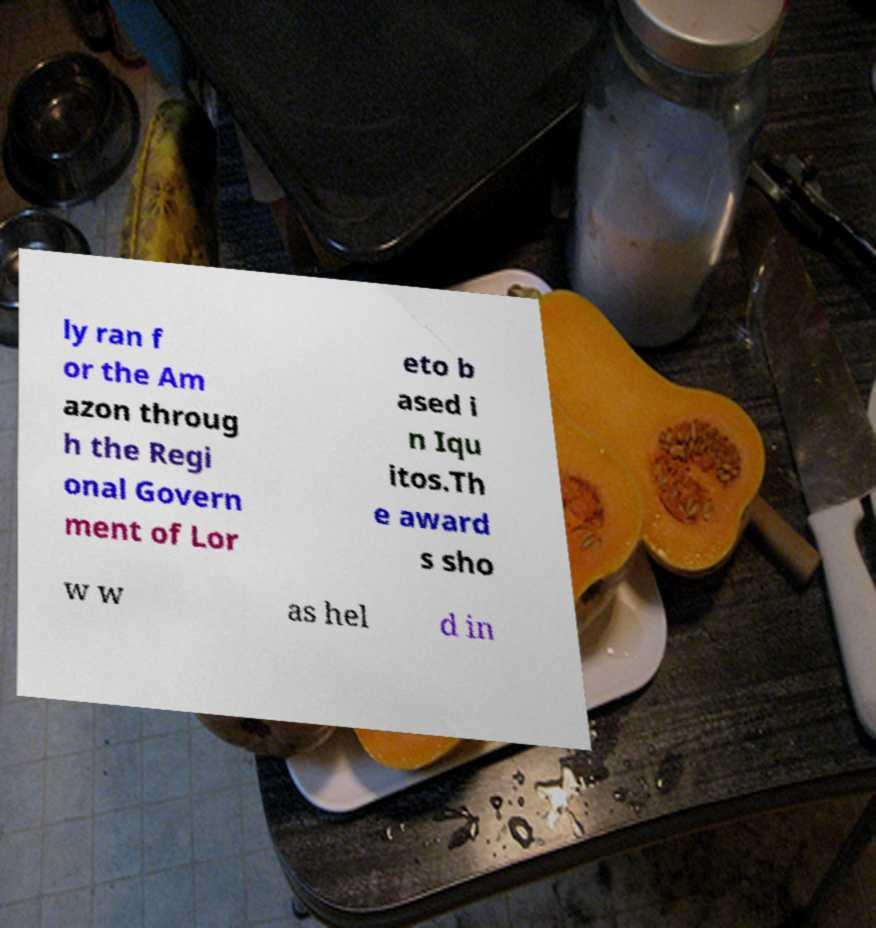Could you assist in decoding the text presented in this image and type it out clearly? ly ran f or the Am azon throug h the Regi onal Govern ment of Lor eto b ased i n Iqu itos.Th e award s sho w w as hel d in 